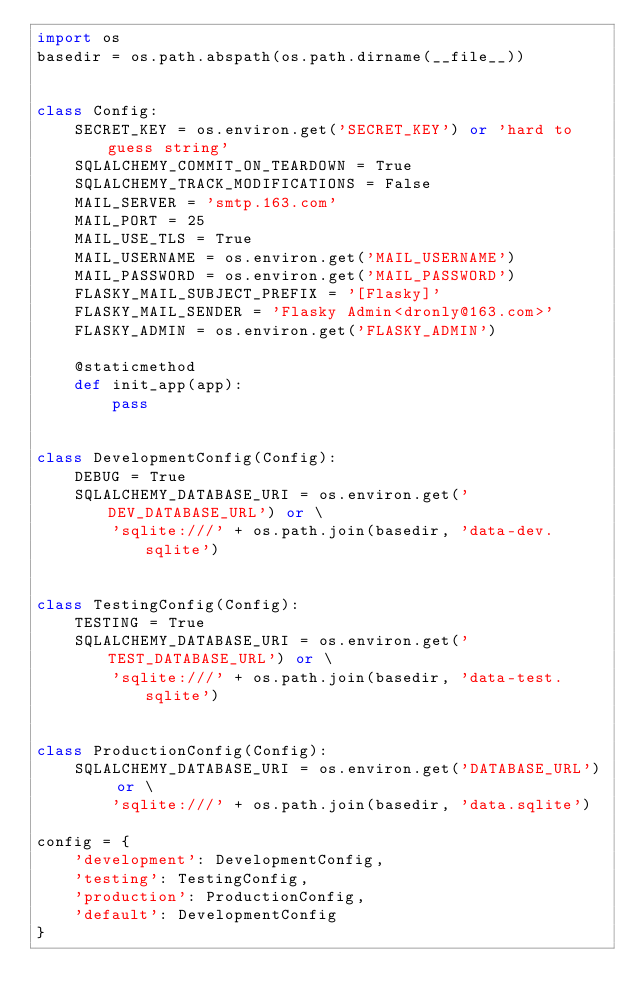Convert code to text. <code><loc_0><loc_0><loc_500><loc_500><_Python_>import os
basedir = os.path.abspath(os.path.dirname(__file__))


class Config:
    SECRET_KEY = os.environ.get('SECRET_KEY') or 'hard to guess string'
    SQLALCHEMY_COMMIT_ON_TEARDOWN = True
    SQLALCHEMY_TRACK_MODIFICATIONS = False
    MAIL_SERVER = 'smtp.163.com'
    MAIL_PORT = 25
    MAIL_USE_TLS = True
    MAIL_USERNAME = os.environ.get('MAIL_USERNAME')
    MAIL_PASSWORD = os.environ.get('MAIL_PASSWORD')
    FLASKY_MAIL_SUBJECT_PREFIX = '[Flasky]'
    FLASKY_MAIL_SENDER = 'Flasky Admin<dronly@163.com>'
    FLASKY_ADMIN = os.environ.get('FLASKY_ADMIN')

    @staticmethod
    def init_app(app):
        pass


class DevelopmentConfig(Config):
    DEBUG = True
    SQLALCHEMY_DATABASE_URI = os.environ.get('DEV_DATABASE_URL') or \
        'sqlite:///' + os.path.join(basedir, 'data-dev.sqlite')


class TestingConfig(Config):
    TESTING = True
    SQLALCHEMY_DATABASE_URI = os.environ.get('TEST_DATABASE_URL') or \
        'sqlite:///' + os.path.join(basedir, 'data-test.sqlite')


class ProductionConfig(Config):
    SQLALCHEMY_DATABASE_URI = os.environ.get('DATABASE_URL') or \
        'sqlite:///' + os.path.join(basedir, 'data.sqlite')

config = {
    'development': DevelopmentConfig,
    'testing': TestingConfig,
    'production': ProductionConfig,
    'default': DevelopmentConfig
}</code> 